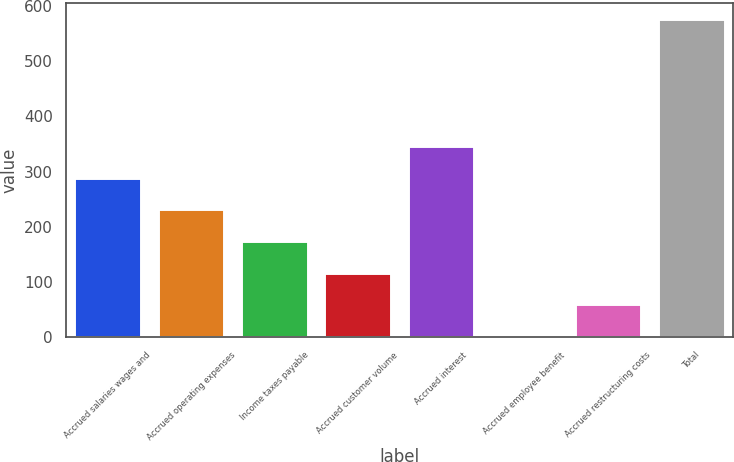Convert chart. <chart><loc_0><loc_0><loc_500><loc_500><bar_chart><fcel>Accrued salaries wages and<fcel>Accrued operating expenses<fcel>Income taxes payable<fcel>Accrued customer volume<fcel>Accrued interest<fcel>Accrued employee benefit<fcel>Accrued restructuring costs<fcel>Total<nl><fcel>289.25<fcel>231.86<fcel>174.47<fcel>117.08<fcel>346.64<fcel>2.3<fcel>59.69<fcel>576.2<nl></chart> 